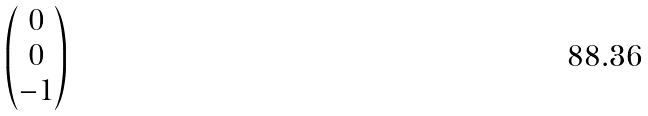Convert formula to latex. <formula><loc_0><loc_0><loc_500><loc_500>\begin{pmatrix} 0 \\ 0 \\ - 1 \\ \end{pmatrix}</formula> 